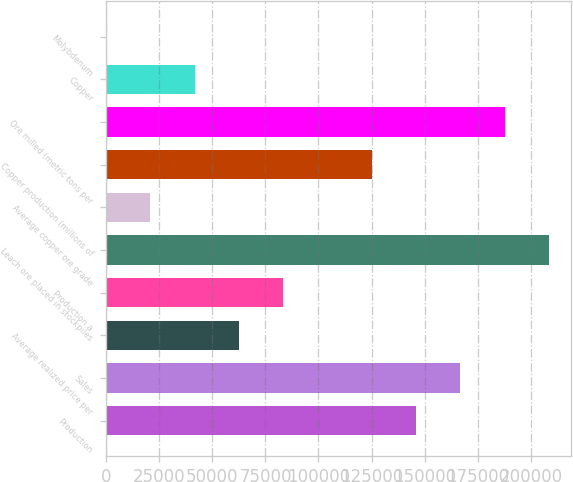Convert chart. <chart><loc_0><loc_0><loc_500><loc_500><bar_chart><fcel>Production<fcel>Sales<fcel>Average realized price per<fcel>Production a<fcel>Leach ore placed in stockpiles<fcel>Average copper ore grade<fcel>Copper production (millions of<fcel>Ore milled (metric tons per<fcel>Copper<fcel>Molybdenum<nl><fcel>145880<fcel>166720<fcel>62520<fcel>83360<fcel>208400<fcel>20840<fcel>125040<fcel>187560<fcel>41680<fcel>0.02<nl></chart> 